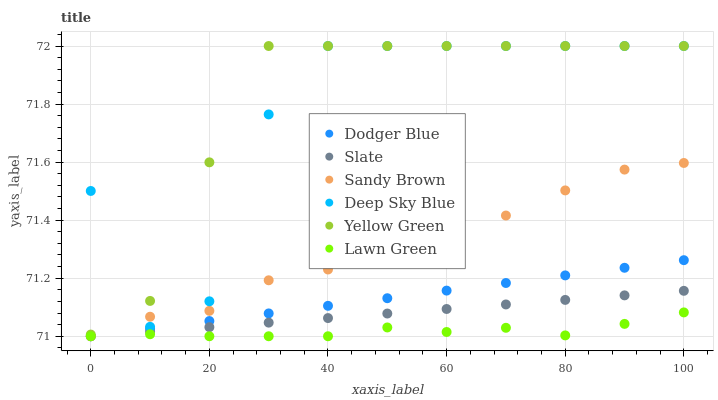Does Lawn Green have the minimum area under the curve?
Answer yes or no. Yes. Does Yellow Green have the maximum area under the curve?
Answer yes or no. Yes. Does Slate have the minimum area under the curve?
Answer yes or no. No. Does Slate have the maximum area under the curve?
Answer yes or no. No. Is Dodger Blue the smoothest?
Answer yes or no. Yes. Is Deep Sky Blue the roughest?
Answer yes or no. Yes. Is Yellow Green the smoothest?
Answer yes or no. No. Is Yellow Green the roughest?
Answer yes or no. No. Does Lawn Green have the lowest value?
Answer yes or no. Yes. Does Yellow Green have the lowest value?
Answer yes or no. No. Does Deep Sky Blue have the highest value?
Answer yes or no. Yes. Does Slate have the highest value?
Answer yes or no. No. Is Lawn Green less than Deep Sky Blue?
Answer yes or no. Yes. Is Yellow Green greater than Lawn Green?
Answer yes or no. Yes. Does Lawn Green intersect Slate?
Answer yes or no. Yes. Is Lawn Green less than Slate?
Answer yes or no. No. Is Lawn Green greater than Slate?
Answer yes or no. No. Does Lawn Green intersect Deep Sky Blue?
Answer yes or no. No. 